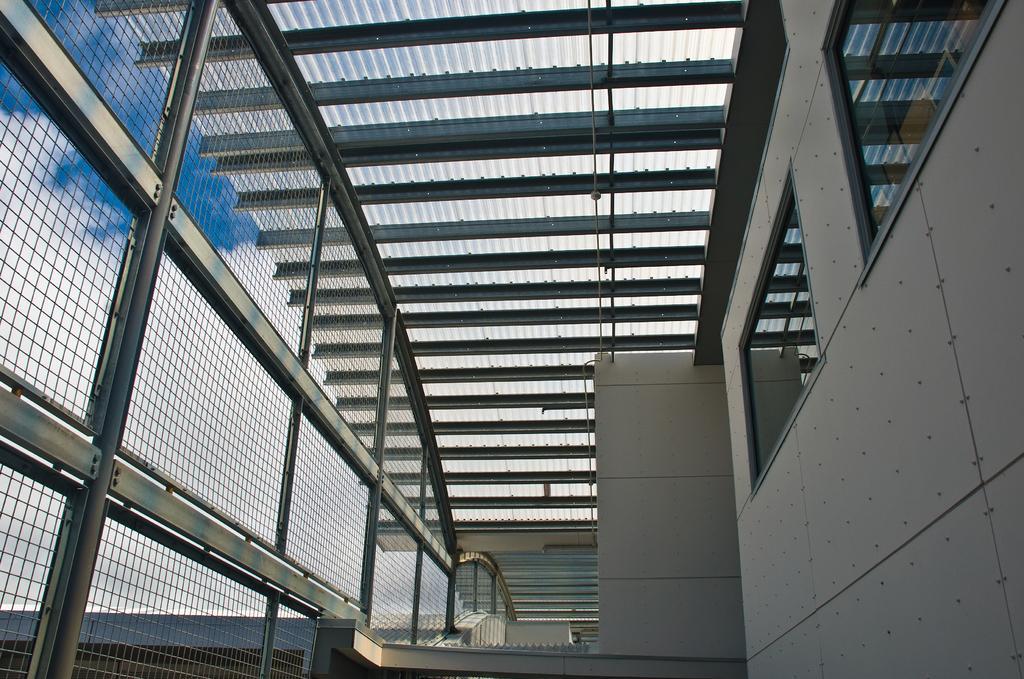Describe this image in one or two sentences. In this image I can see the inner part of the building and I can also see few windows and grills. Background the sky is in white and blue color. 